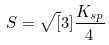Convert formula to latex. <formula><loc_0><loc_0><loc_500><loc_500>S = \sqrt { [ } 3 ] { \frac { K _ { s p } } { 4 } }</formula> 